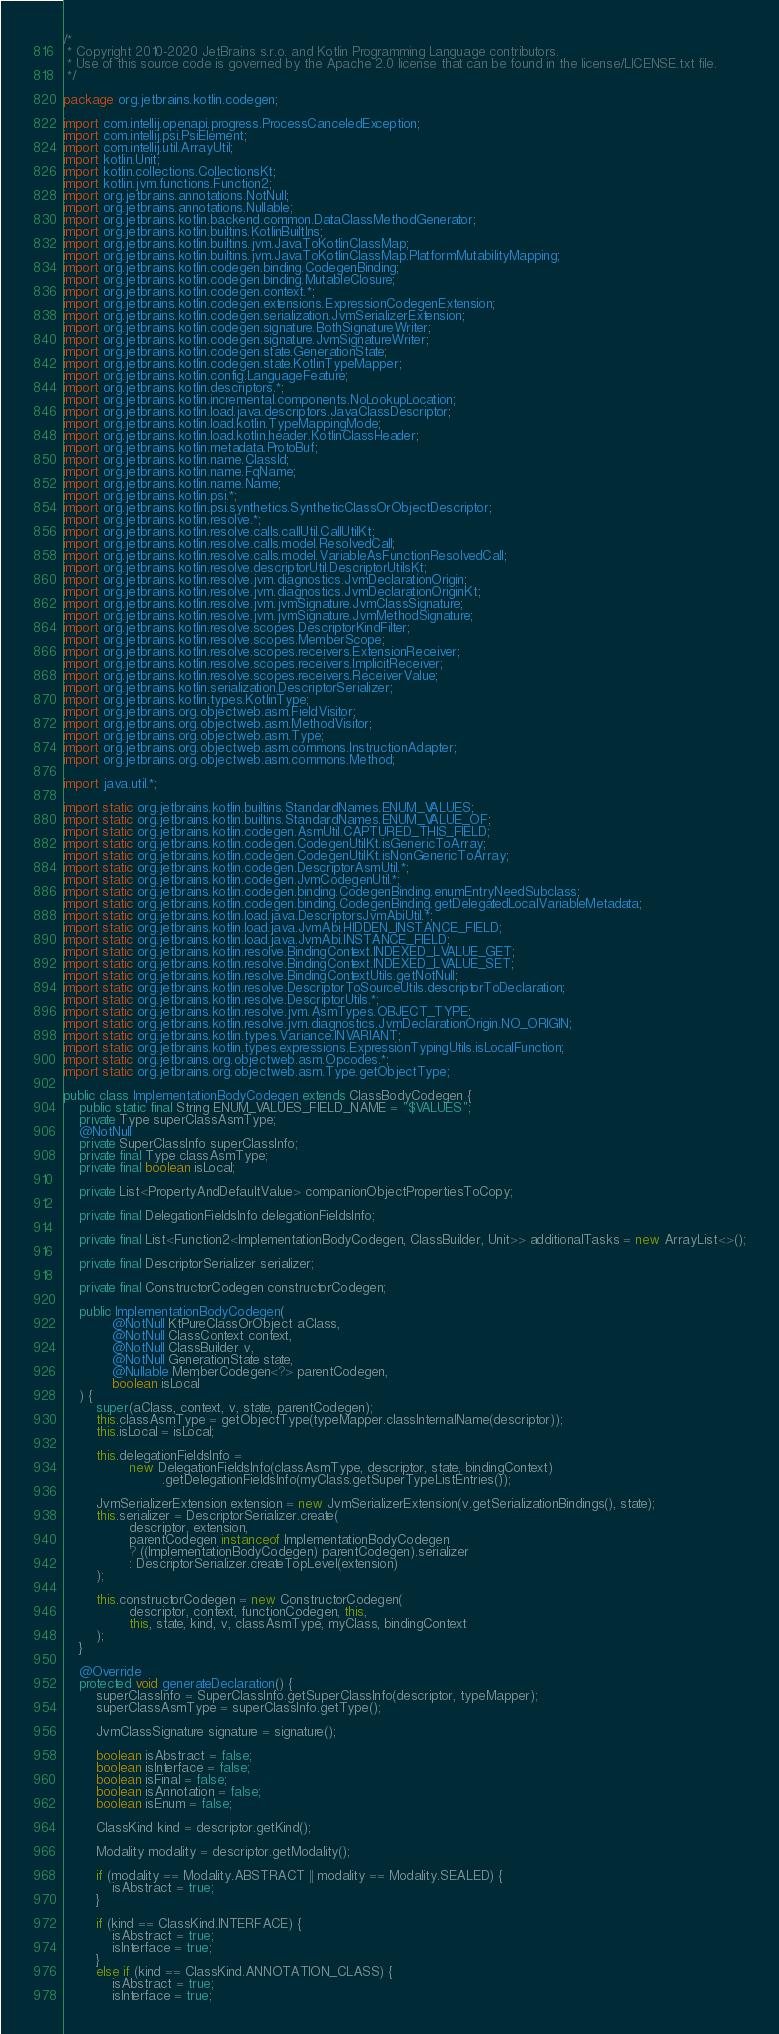Convert code to text. <code><loc_0><loc_0><loc_500><loc_500><_Java_>/*
 * Copyright 2010-2020 JetBrains s.r.o. and Kotlin Programming Language contributors.
 * Use of this source code is governed by the Apache 2.0 license that can be found in the license/LICENSE.txt file.
 */

package org.jetbrains.kotlin.codegen;

import com.intellij.openapi.progress.ProcessCanceledException;
import com.intellij.psi.PsiElement;
import com.intellij.util.ArrayUtil;
import kotlin.Unit;
import kotlin.collections.CollectionsKt;
import kotlin.jvm.functions.Function2;
import org.jetbrains.annotations.NotNull;
import org.jetbrains.annotations.Nullable;
import org.jetbrains.kotlin.backend.common.DataClassMethodGenerator;
import org.jetbrains.kotlin.builtins.KotlinBuiltIns;
import org.jetbrains.kotlin.builtins.jvm.JavaToKotlinClassMap;
import org.jetbrains.kotlin.builtins.jvm.JavaToKotlinClassMap.PlatformMutabilityMapping;
import org.jetbrains.kotlin.codegen.binding.CodegenBinding;
import org.jetbrains.kotlin.codegen.binding.MutableClosure;
import org.jetbrains.kotlin.codegen.context.*;
import org.jetbrains.kotlin.codegen.extensions.ExpressionCodegenExtension;
import org.jetbrains.kotlin.codegen.serialization.JvmSerializerExtension;
import org.jetbrains.kotlin.codegen.signature.BothSignatureWriter;
import org.jetbrains.kotlin.codegen.signature.JvmSignatureWriter;
import org.jetbrains.kotlin.codegen.state.GenerationState;
import org.jetbrains.kotlin.codegen.state.KotlinTypeMapper;
import org.jetbrains.kotlin.config.LanguageFeature;
import org.jetbrains.kotlin.descriptors.*;
import org.jetbrains.kotlin.incremental.components.NoLookupLocation;
import org.jetbrains.kotlin.load.java.descriptors.JavaClassDescriptor;
import org.jetbrains.kotlin.load.kotlin.TypeMappingMode;
import org.jetbrains.kotlin.load.kotlin.header.KotlinClassHeader;
import org.jetbrains.kotlin.metadata.ProtoBuf;
import org.jetbrains.kotlin.name.ClassId;
import org.jetbrains.kotlin.name.FqName;
import org.jetbrains.kotlin.name.Name;
import org.jetbrains.kotlin.psi.*;
import org.jetbrains.kotlin.psi.synthetics.SyntheticClassOrObjectDescriptor;
import org.jetbrains.kotlin.resolve.*;
import org.jetbrains.kotlin.resolve.calls.callUtil.CallUtilKt;
import org.jetbrains.kotlin.resolve.calls.model.ResolvedCall;
import org.jetbrains.kotlin.resolve.calls.model.VariableAsFunctionResolvedCall;
import org.jetbrains.kotlin.resolve.descriptorUtil.DescriptorUtilsKt;
import org.jetbrains.kotlin.resolve.jvm.diagnostics.JvmDeclarationOrigin;
import org.jetbrains.kotlin.resolve.jvm.diagnostics.JvmDeclarationOriginKt;
import org.jetbrains.kotlin.resolve.jvm.jvmSignature.JvmClassSignature;
import org.jetbrains.kotlin.resolve.jvm.jvmSignature.JvmMethodSignature;
import org.jetbrains.kotlin.resolve.scopes.DescriptorKindFilter;
import org.jetbrains.kotlin.resolve.scopes.MemberScope;
import org.jetbrains.kotlin.resolve.scopes.receivers.ExtensionReceiver;
import org.jetbrains.kotlin.resolve.scopes.receivers.ImplicitReceiver;
import org.jetbrains.kotlin.resolve.scopes.receivers.ReceiverValue;
import org.jetbrains.kotlin.serialization.DescriptorSerializer;
import org.jetbrains.kotlin.types.KotlinType;
import org.jetbrains.org.objectweb.asm.FieldVisitor;
import org.jetbrains.org.objectweb.asm.MethodVisitor;
import org.jetbrains.org.objectweb.asm.Type;
import org.jetbrains.org.objectweb.asm.commons.InstructionAdapter;
import org.jetbrains.org.objectweb.asm.commons.Method;

import java.util.*;

import static org.jetbrains.kotlin.builtins.StandardNames.ENUM_VALUES;
import static org.jetbrains.kotlin.builtins.StandardNames.ENUM_VALUE_OF;
import static org.jetbrains.kotlin.codegen.AsmUtil.CAPTURED_THIS_FIELD;
import static org.jetbrains.kotlin.codegen.CodegenUtilKt.isGenericToArray;
import static org.jetbrains.kotlin.codegen.CodegenUtilKt.isNonGenericToArray;
import static org.jetbrains.kotlin.codegen.DescriptorAsmUtil.*;
import static org.jetbrains.kotlin.codegen.JvmCodegenUtil.*;
import static org.jetbrains.kotlin.codegen.binding.CodegenBinding.enumEntryNeedSubclass;
import static org.jetbrains.kotlin.codegen.binding.CodegenBinding.getDelegatedLocalVariableMetadata;
import static org.jetbrains.kotlin.load.java.DescriptorsJvmAbiUtil.*;
import static org.jetbrains.kotlin.load.java.JvmAbi.HIDDEN_INSTANCE_FIELD;
import static org.jetbrains.kotlin.load.java.JvmAbi.INSTANCE_FIELD;
import static org.jetbrains.kotlin.resolve.BindingContext.INDEXED_LVALUE_GET;
import static org.jetbrains.kotlin.resolve.BindingContext.INDEXED_LVALUE_SET;
import static org.jetbrains.kotlin.resolve.BindingContextUtils.getNotNull;
import static org.jetbrains.kotlin.resolve.DescriptorToSourceUtils.descriptorToDeclaration;
import static org.jetbrains.kotlin.resolve.DescriptorUtils.*;
import static org.jetbrains.kotlin.resolve.jvm.AsmTypes.OBJECT_TYPE;
import static org.jetbrains.kotlin.resolve.jvm.diagnostics.JvmDeclarationOrigin.NO_ORIGIN;
import static org.jetbrains.kotlin.types.Variance.INVARIANT;
import static org.jetbrains.kotlin.types.expressions.ExpressionTypingUtils.isLocalFunction;
import static org.jetbrains.org.objectweb.asm.Opcodes.*;
import static org.jetbrains.org.objectweb.asm.Type.getObjectType;

public class ImplementationBodyCodegen extends ClassBodyCodegen {
    public static final String ENUM_VALUES_FIELD_NAME = "$VALUES";
    private Type superClassAsmType;
    @NotNull
    private SuperClassInfo superClassInfo;
    private final Type classAsmType;
    private final boolean isLocal;

    private List<PropertyAndDefaultValue> companionObjectPropertiesToCopy;

    private final DelegationFieldsInfo delegationFieldsInfo;

    private final List<Function2<ImplementationBodyCodegen, ClassBuilder, Unit>> additionalTasks = new ArrayList<>();

    private final DescriptorSerializer serializer;

    private final ConstructorCodegen constructorCodegen;

    public ImplementationBodyCodegen(
            @NotNull KtPureClassOrObject aClass,
            @NotNull ClassContext context,
            @NotNull ClassBuilder v,
            @NotNull GenerationState state,
            @Nullable MemberCodegen<?> parentCodegen,
            boolean isLocal
    ) {
        super(aClass, context, v, state, parentCodegen);
        this.classAsmType = getObjectType(typeMapper.classInternalName(descriptor));
        this.isLocal = isLocal;

        this.delegationFieldsInfo =
                new DelegationFieldsInfo(classAsmType, descriptor, state, bindingContext)
                        .getDelegationFieldsInfo(myClass.getSuperTypeListEntries());

        JvmSerializerExtension extension = new JvmSerializerExtension(v.getSerializationBindings(), state);
        this.serializer = DescriptorSerializer.create(
                descriptor, extension,
                parentCodegen instanceof ImplementationBodyCodegen
                ? ((ImplementationBodyCodegen) parentCodegen).serializer
                : DescriptorSerializer.createTopLevel(extension)
        );

        this.constructorCodegen = new ConstructorCodegen(
                descriptor, context, functionCodegen, this,
                this, state, kind, v, classAsmType, myClass, bindingContext
        );
    }

    @Override
    protected void generateDeclaration() {
        superClassInfo = SuperClassInfo.getSuperClassInfo(descriptor, typeMapper);
        superClassAsmType = superClassInfo.getType();

        JvmClassSignature signature = signature();

        boolean isAbstract = false;
        boolean isInterface = false;
        boolean isFinal = false;
        boolean isAnnotation = false;
        boolean isEnum = false;

        ClassKind kind = descriptor.getKind();

        Modality modality = descriptor.getModality();

        if (modality == Modality.ABSTRACT || modality == Modality.SEALED) {
            isAbstract = true;
        }

        if (kind == ClassKind.INTERFACE) {
            isAbstract = true;
            isInterface = true;
        }
        else if (kind == ClassKind.ANNOTATION_CLASS) {
            isAbstract = true;
            isInterface = true;</code> 